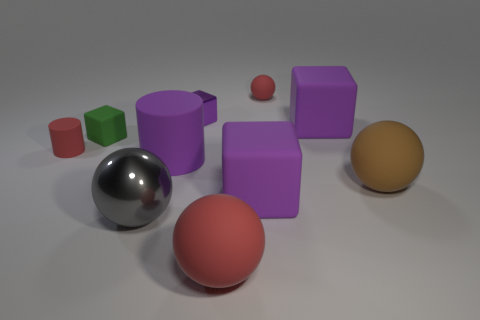Subtract all blue cylinders. How many purple cubes are left? 3 Subtract 1 balls. How many balls are left? 3 Subtract all cyan spheres. Subtract all gray cylinders. How many spheres are left? 4 Subtract all cylinders. How many objects are left? 8 Add 2 big red matte objects. How many big red matte objects are left? 3 Add 5 shiny spheres. How many shiny spheres exist? 6 Subtract 0 blue spheres. How many objects are left? 10 Subtract all brown balls. Subtract all brown things. How many objects are left? 8 